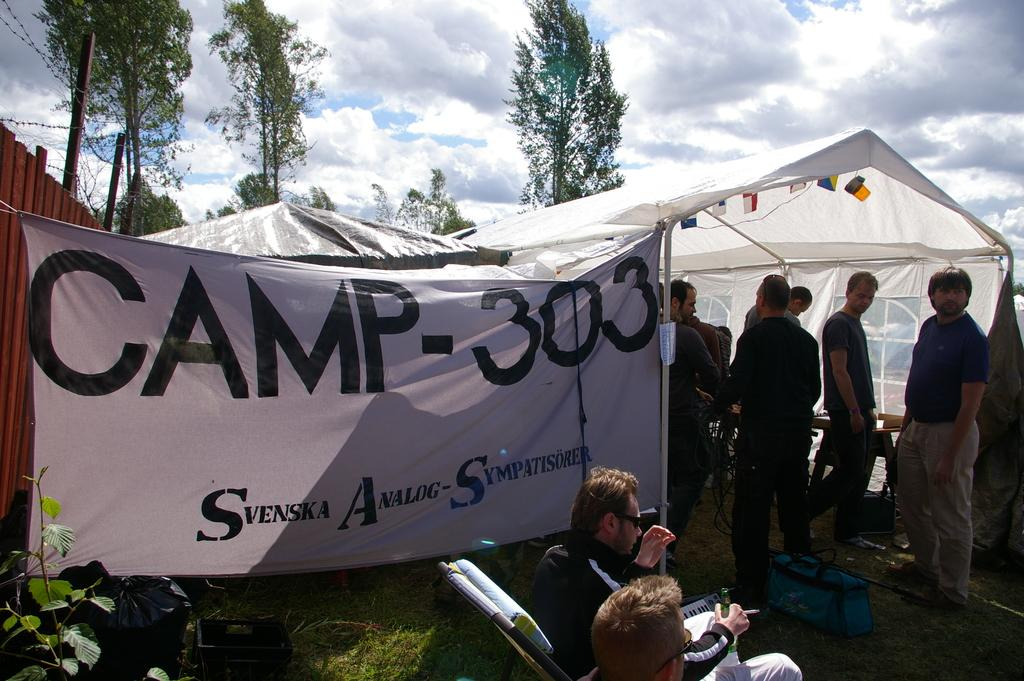Where are the persons located in the image? The persons are under the tent in the image. What is present at the bottom of the image? There is a plant and a person sitting on a chair at the bottom of the image. What can be seen in the background of the image? There are trees, the sky, and clouds visible in the background of the image. What type of wood is used to create the border around the image? There is no border around the image, and therefore no wood is present. What is the cork doing in the image? There is no cork present in the image. 